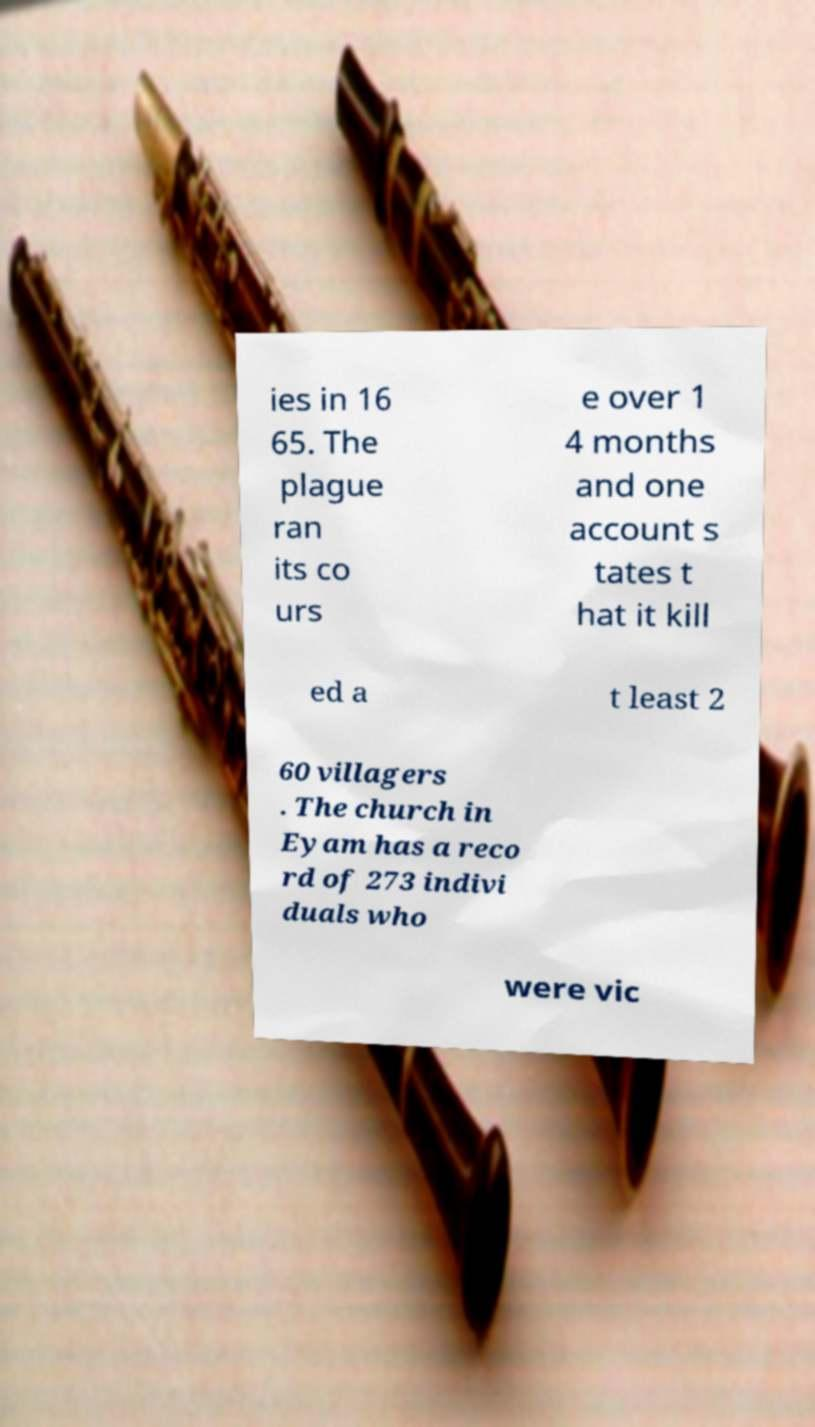Please identify and transcribe the text found in this image. ies in 16 65. The plague ran its co urs e over 1 4 months and one account s tates t hat it kill ed a t least 2 60 villagers . The church in Eyam has a reco rd of 273 indivi duals who were vic 